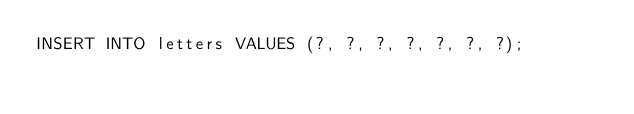<code> <loc_0><loc_0><loc_500><loc_500><_SQL_>INSERT INTO letters VALUES (?, ?, ?, ?, ?, ?, ?);</code> 